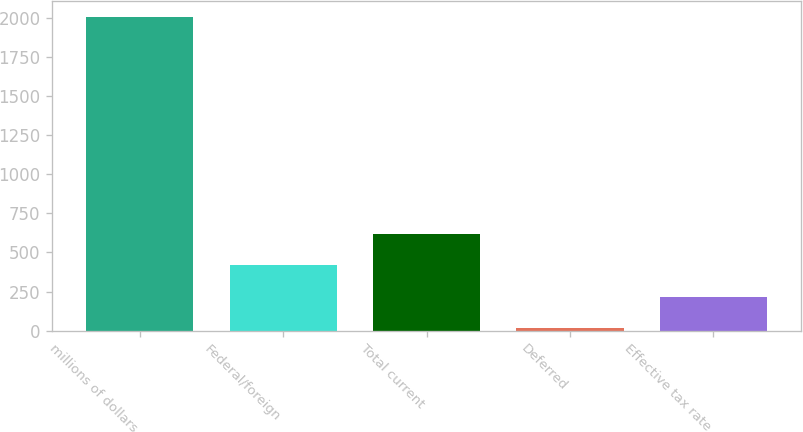<chart> <loc_0><loc_0><loc_500><loc_500><bar_chart><fcel>millions of dollars<fcel>Federal/foreign<fcel>Total current<fcel>Deferred<fcel>Effective tax rate<nl><fcel>2006<fcel>416.4<fcel>615.1<fcel>19<fcel>217.7<nl></chart> 